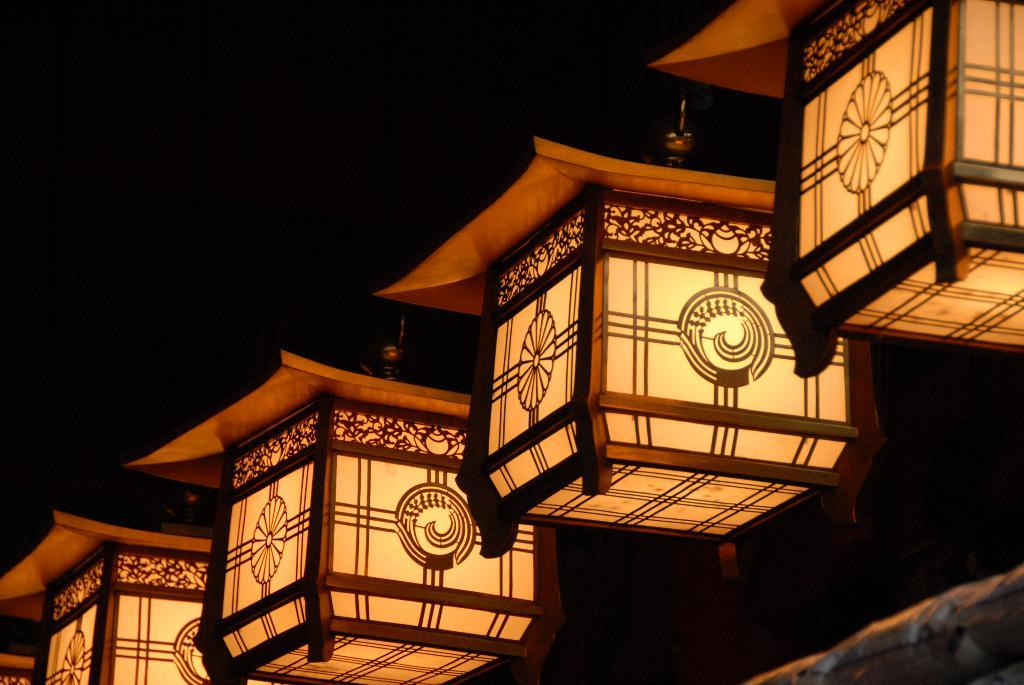What objects are present in the image? There are lanterns in the image. What can be observed about the background of the image? The background of the image is dark. How does the judge react to the expansion of the lanterns in the image? There is no judge or expansion of lanterns present in the image. 